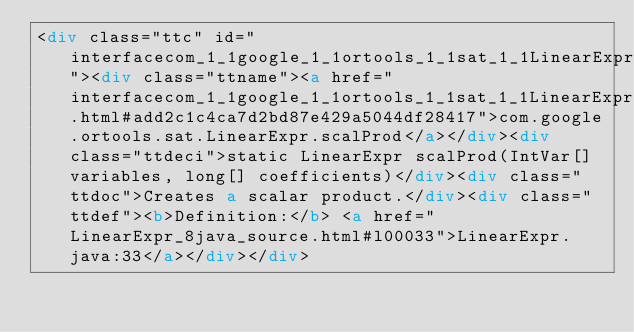Convert code to text. <code><loc_0><loc_0><loc_500><loc_500><_HTML_><div class="ttc" id="interfacecom_1_1google_1_1ortools_1_1sat_1_1LinearExpr_html_add2c1c4ca7d2bd87e429a5044df28417"><div class="ttname"><a href="interfacecom_1_1google_1_1ortools_1_1sat_1_1LinearExpr.html#add2c1c4ca7d2bd87e429a5044df28417">com.google.ortools.sat.LinearExpr.scalProd</a></div><div class="ttdeci">static LinearExpr scalProd(IntVar[] variables, long[] coefficients)</div><div class="ttdoc">Creates a scalar product.</div><div class="ttdef"><b>Definition:</b> <a href="LinearExpr_8java_source.html#l00033">LinearExpr.java:33</a></div></div></code> 